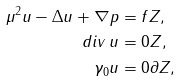<formula> <loc_0><loc_0><loc_500><loc_500>\mu ^ { 2 } u - \Delta u + \nabla p & = f Z , \\ d i v \, u & = 0 Z , \\ \gamma _ { 0 } u & = 0 \partial Z ,</formula> 